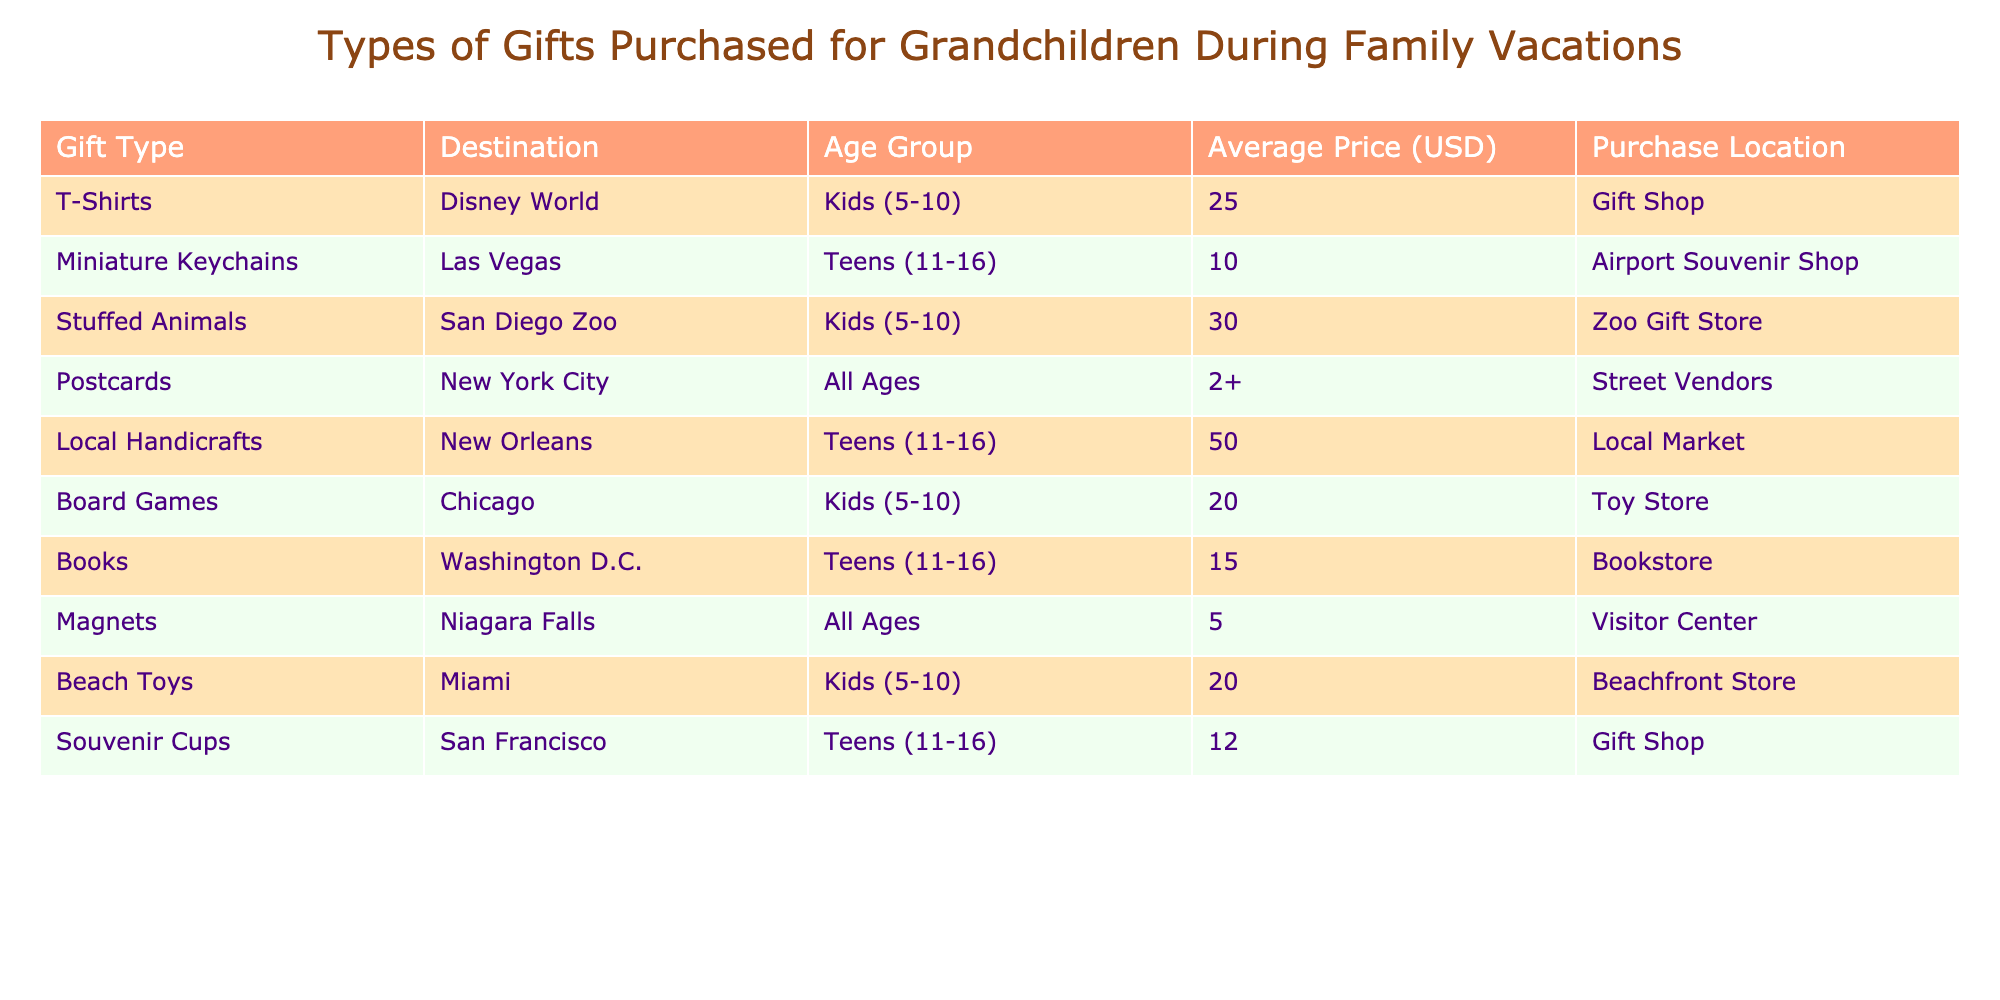What is the average price of T-Shirts purchased for grandchildren? The price for T-Shirts is $25 as listed in the table. There is only one entry for T-Shirts, so the average price is the same as the listed price.
Answer: 25 In which destination were stuffed animals purchased? The table indicates that stuffed animals were purchased in San Diego Zoo, as it is stated in the 'Destination' column next to the 'Stuffed Animals' entry.
Answer: San Diego Zoo How many gifts are listed for the Kids (5-10) age group? From the table, there are three entries for the Kids (5-10) age group: T-Shirts, Stuffed Animals, and Board Games. Therefore, there are 3 gifts listed for this age group.
Answer: 3 What is the total average price of gifts purchased for the Teens (11-16) age group? The average prices for gifts for the Teens (11-16) age group are Miniature Keychains at $10, Local Handicrafts at $50, Books at $15, and Souvenir Cups at $12. Adding these values: 10 + 50 + 15 + 12 = 87. To find the average, divide by the number of gifts (4): 87 / 4 = 21.75.
Answer: 21.75 Is it true that all gifts for kids (5-10) have an average price greater than $15? The average prices for gifts for kids (5-10) are: T-Shirts at $25, Stuffed Animals at $30, and Board Games at $20. All three are indeed greater than $15, hence the statement is true.
Answer: True Which gift has the lowest average price, and what is that price? Upon reviewing the table, the lowest average price listed is for Postcards at $2 (which applies to the All Ages category). As this is the minimum value, Postcards are the gift with the lowest price.
Answer: 2 What type of gifts are available for all ages, and what is their average price? According to the table, the only gifts available for all ages are Postcards ($2) and Magnets ($5). To find the average price, sum them: 2 + 5 = 7, and then divide by 2 (the number of gifts): 7 / 2 = 3.5. Therefore, the average price for gifts available for all ages is $3.5.
Answer: 3.5 Are beach toys purchased for grandchildren at a higher average price than magnets? Beach Toys have an average price of $20, while Magnets have an average price of $5. Since $20 is greater than $5, this statement is true.
Answer: True What is the most expensive gift listed, and where was it purchased? From the table, the most expensive gift is Local Handicrafts at $50, which was purchased at a Local Market. Therefore, the answer includes both the gift type and its purchase location.
Answer: Local Handicrafts, Local Market 